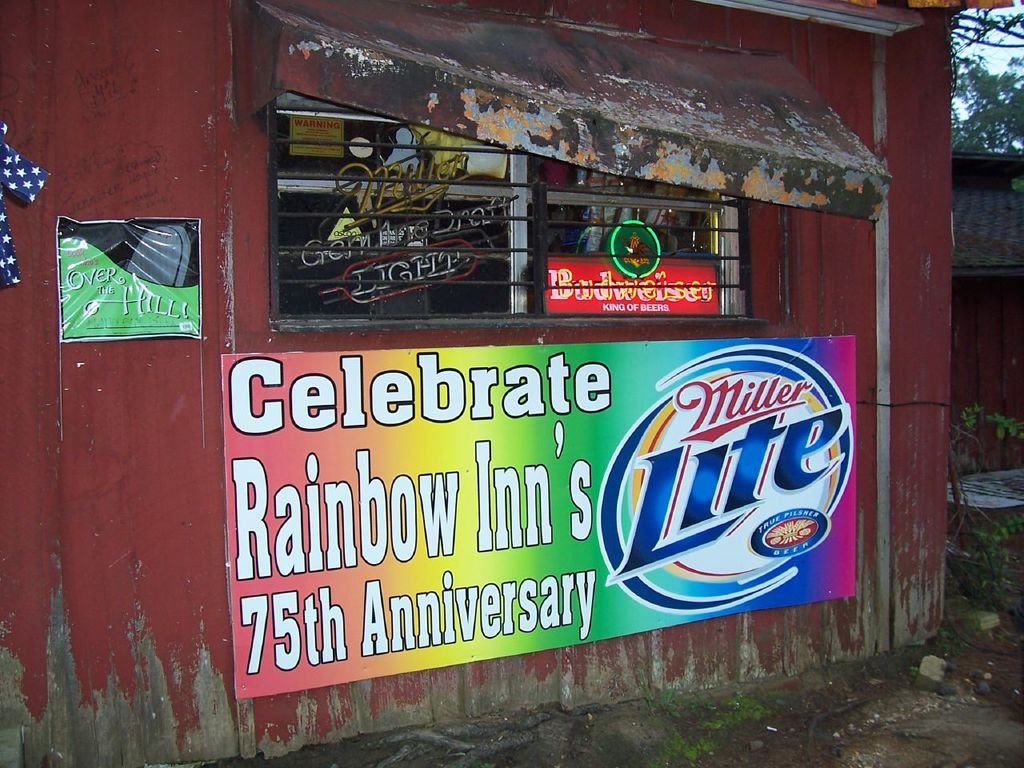What are the key elements in this picture? This image showcases the Rainbow Inn celebrating its 75th anniversary, marked by a vivid, colorful sign featuring the Miller Lite logo, indicating their likely sponsorship. The inn itself is a rustic building with a worn red paint job, prominently displaying character through a window brimming with neon signs and aged wooden architecture. Prominent decorations include an 'Open' neon sign and a patriotic American flag, contributing to an inviting, festive atmosphere. The scene is set in a natural, possibly wooded area, enhancing the quaint and historic charm of the inn. 